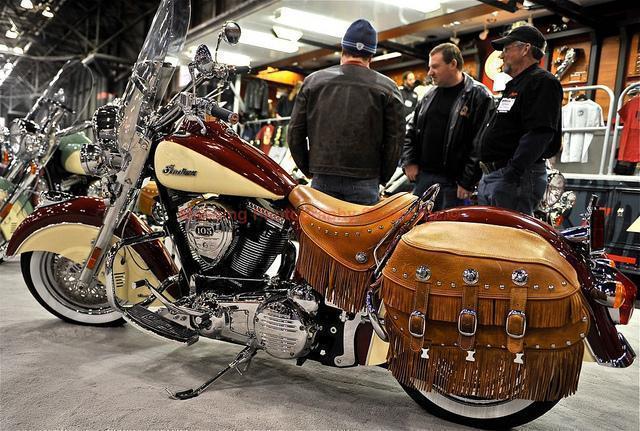What style is this bike decorated in?
Select the accurate response from the four choices given to answer the question.
Options: Chef, golfer, cowboy, jock. Cowboy. 